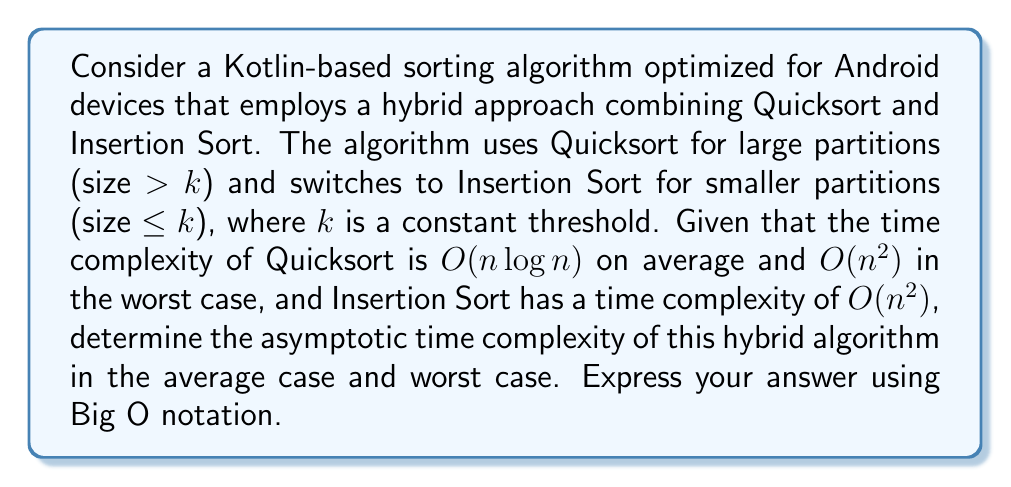Could you help me with this problem? To determine the asymptotic time complexity of this hybrid algorithm, we need to analyze its behavior in both average and worst-case scenarios:

1. Average case analysis:
   In the average case, Quicksort partitions the array into roughly equal halves at each recursive step. The recurrence relation for this hybrid algorithm can be expressed as:

   $$T(n) = \begin{cases}
   O(n^2) & \text{if } n \leq k \\
   2T(n/2) + O(n) & \text{if } n > k
   \end{cases}$$

   Where the O(n) term represents the partitioning step in Quicksort.

   Using the Master Theorem, we can solve this recurrence:
   $a = 2$, $b = 2$, $f(n) = O(n)$

   Since $f(n) = O(n) = O(n^{\log_b a})$, we fall into case 2 of the Master Theorem, giving us:

   $$T(n) = O(n \log n)$$

   The switch to Insertion Sort for small partitions doesn't affect the overall asymptotic complexity in the average case.

2. Worst case analysis:
   In the worst case, Quicksort might consistently choose poor pivots, leading to unbalanced partitions. This results in a recurrence relation:

   $$T(n) = \begin{cases}
   O(n^2) & \text{if } n \leq k \\
   T(n-1) + O(n) & \text{if } n > k
   \end{cases}$$

   Solving this recurrence leads to:

   $$T(n) = O(n^2)$$

   The switch to Insertion Sort for small partitions doesn't improve the worst-case time complexity.

Therefore, the asymptotic time complexity of this hybrid algorithm remains O(n log n) in the average case and O(n²) in the worst case, similar to standard Quicksort.
Answer: Average case: O(n log n)
Worst case: O(n²) 